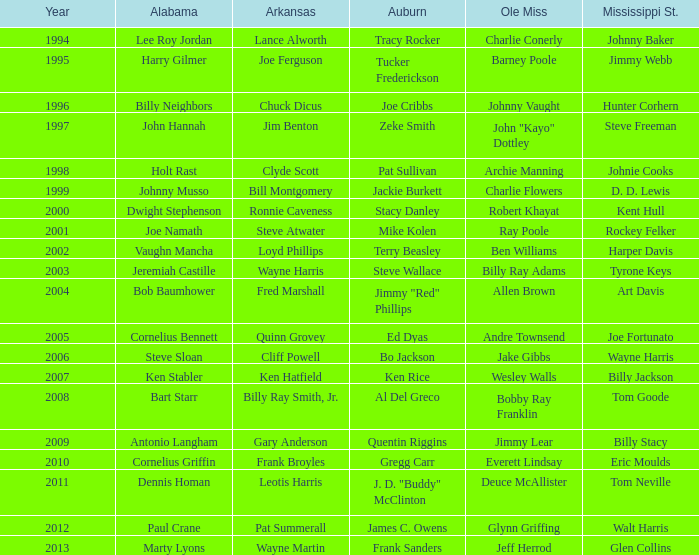Who was the Alabama player associated with Walt Harris? Paul Crane. 